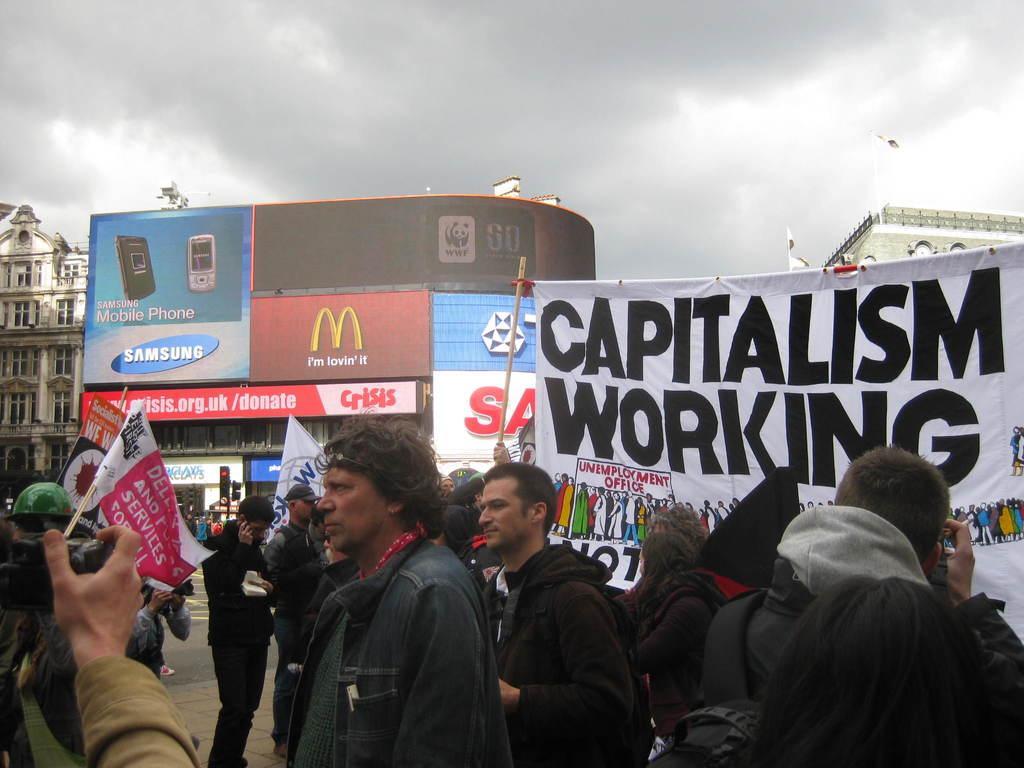Describe this image in one or two sentences. In this image I can see group of people standing and holding few banners. In front the person is holding the camera. In the background I can see few boards, traffic signals, buildings and the sky is in white and gray color. 